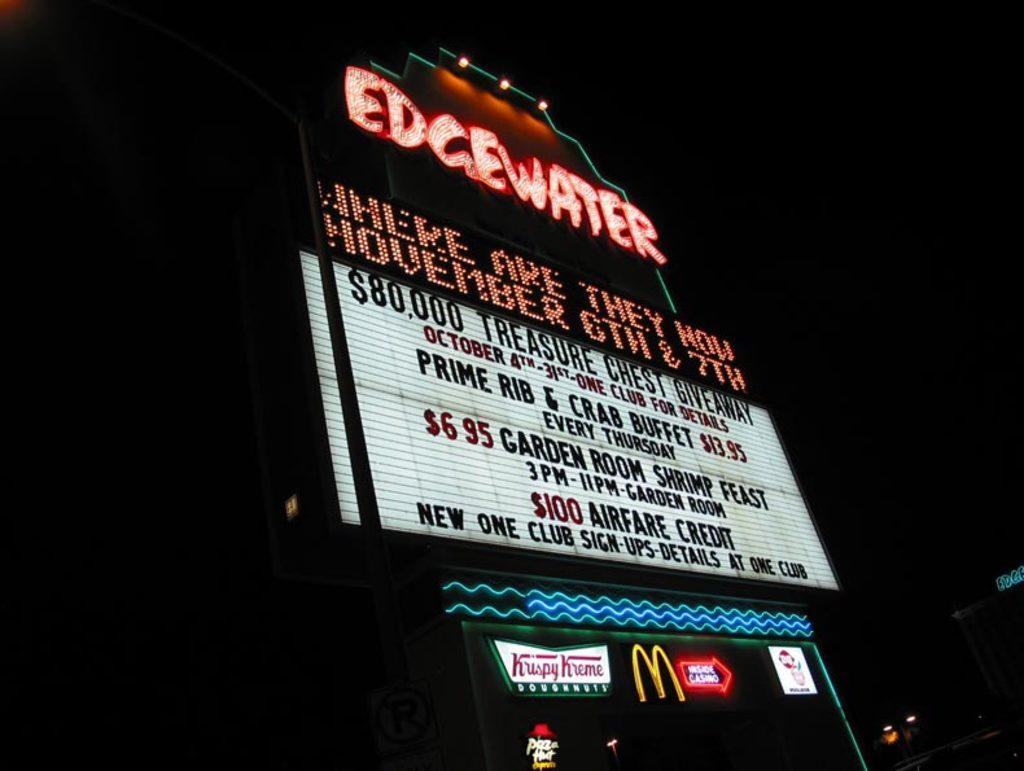<image>
Describe the image concisely. The marquee for the Edgewater says there will be a treasure chest giveaway. 